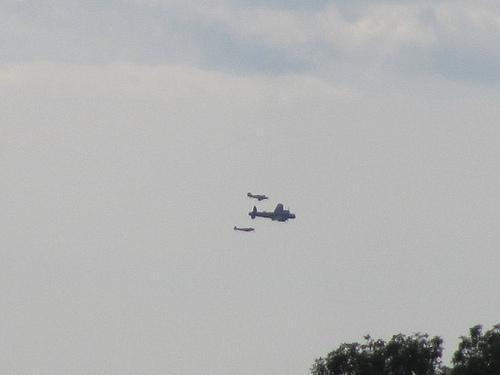How many planes are there?
Give a very brief answer. 3. How many wings does each plane have?
Give a very brief answer. 2. 